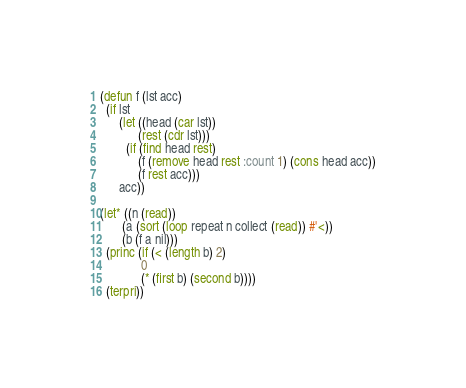<code> <loc_0><loc_0><loc_500><loc_500><_Lisp_>(defun f (lst acc)
  (if lst
      (let ((head (car lst))
            (rest (cdr lst)))
        (if (find head rest)
            (f (remove head rest :count 1) (cons head acc))
            (f rest acc)))
      acc))

(let* ((n (read))
       (a (sort (loop repeat n collect (read)) #'<))
       (b (f a nil)))
  (princ (if (< (length b) 2)
             0
             (* (first b) (second b))))
  (terpri))
</code> 